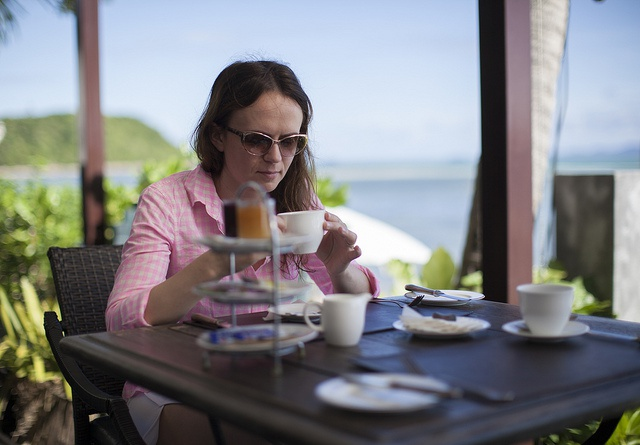Describe the objects in this image and their specific colors. I can see people in darkgreen, black, gray, and darkgray tones, dining table in darkgreen, black, gray, and darkblue tones, chair in darkgreen, black, and gray tones, cup in darkgreen, darkgray, gray, and lightgray tones, and cup in darkgreen, darkgray, gray, and lightgray tones in this image. 